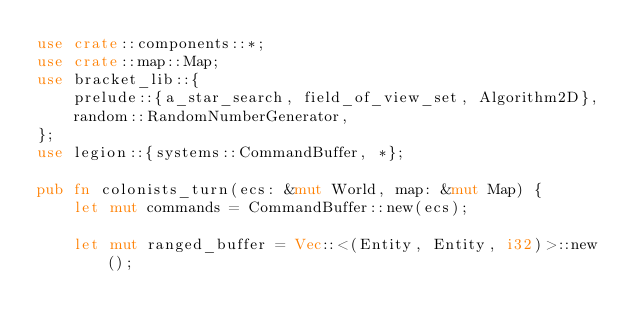<code> <loc_0><loc_0><loc_500><loc_500><_Rust_>use crate::components::*;
use crate::map::Map;
use bracket_lib::{
    prelude::{a_star_search, field_of_view_set, Algorithm2D},
    random::RandomNumberGenerator,
};
use legion::{systems::CommandBuffer, *};

pub fn colonists_turn(ecs: &mut World, map: &mut Map) {
    let mut commands = CommandBuffer::new(ecs);

    let mut ranged_buffer = Vec::<(Entity, Entity, i32)>::new();
</code> 